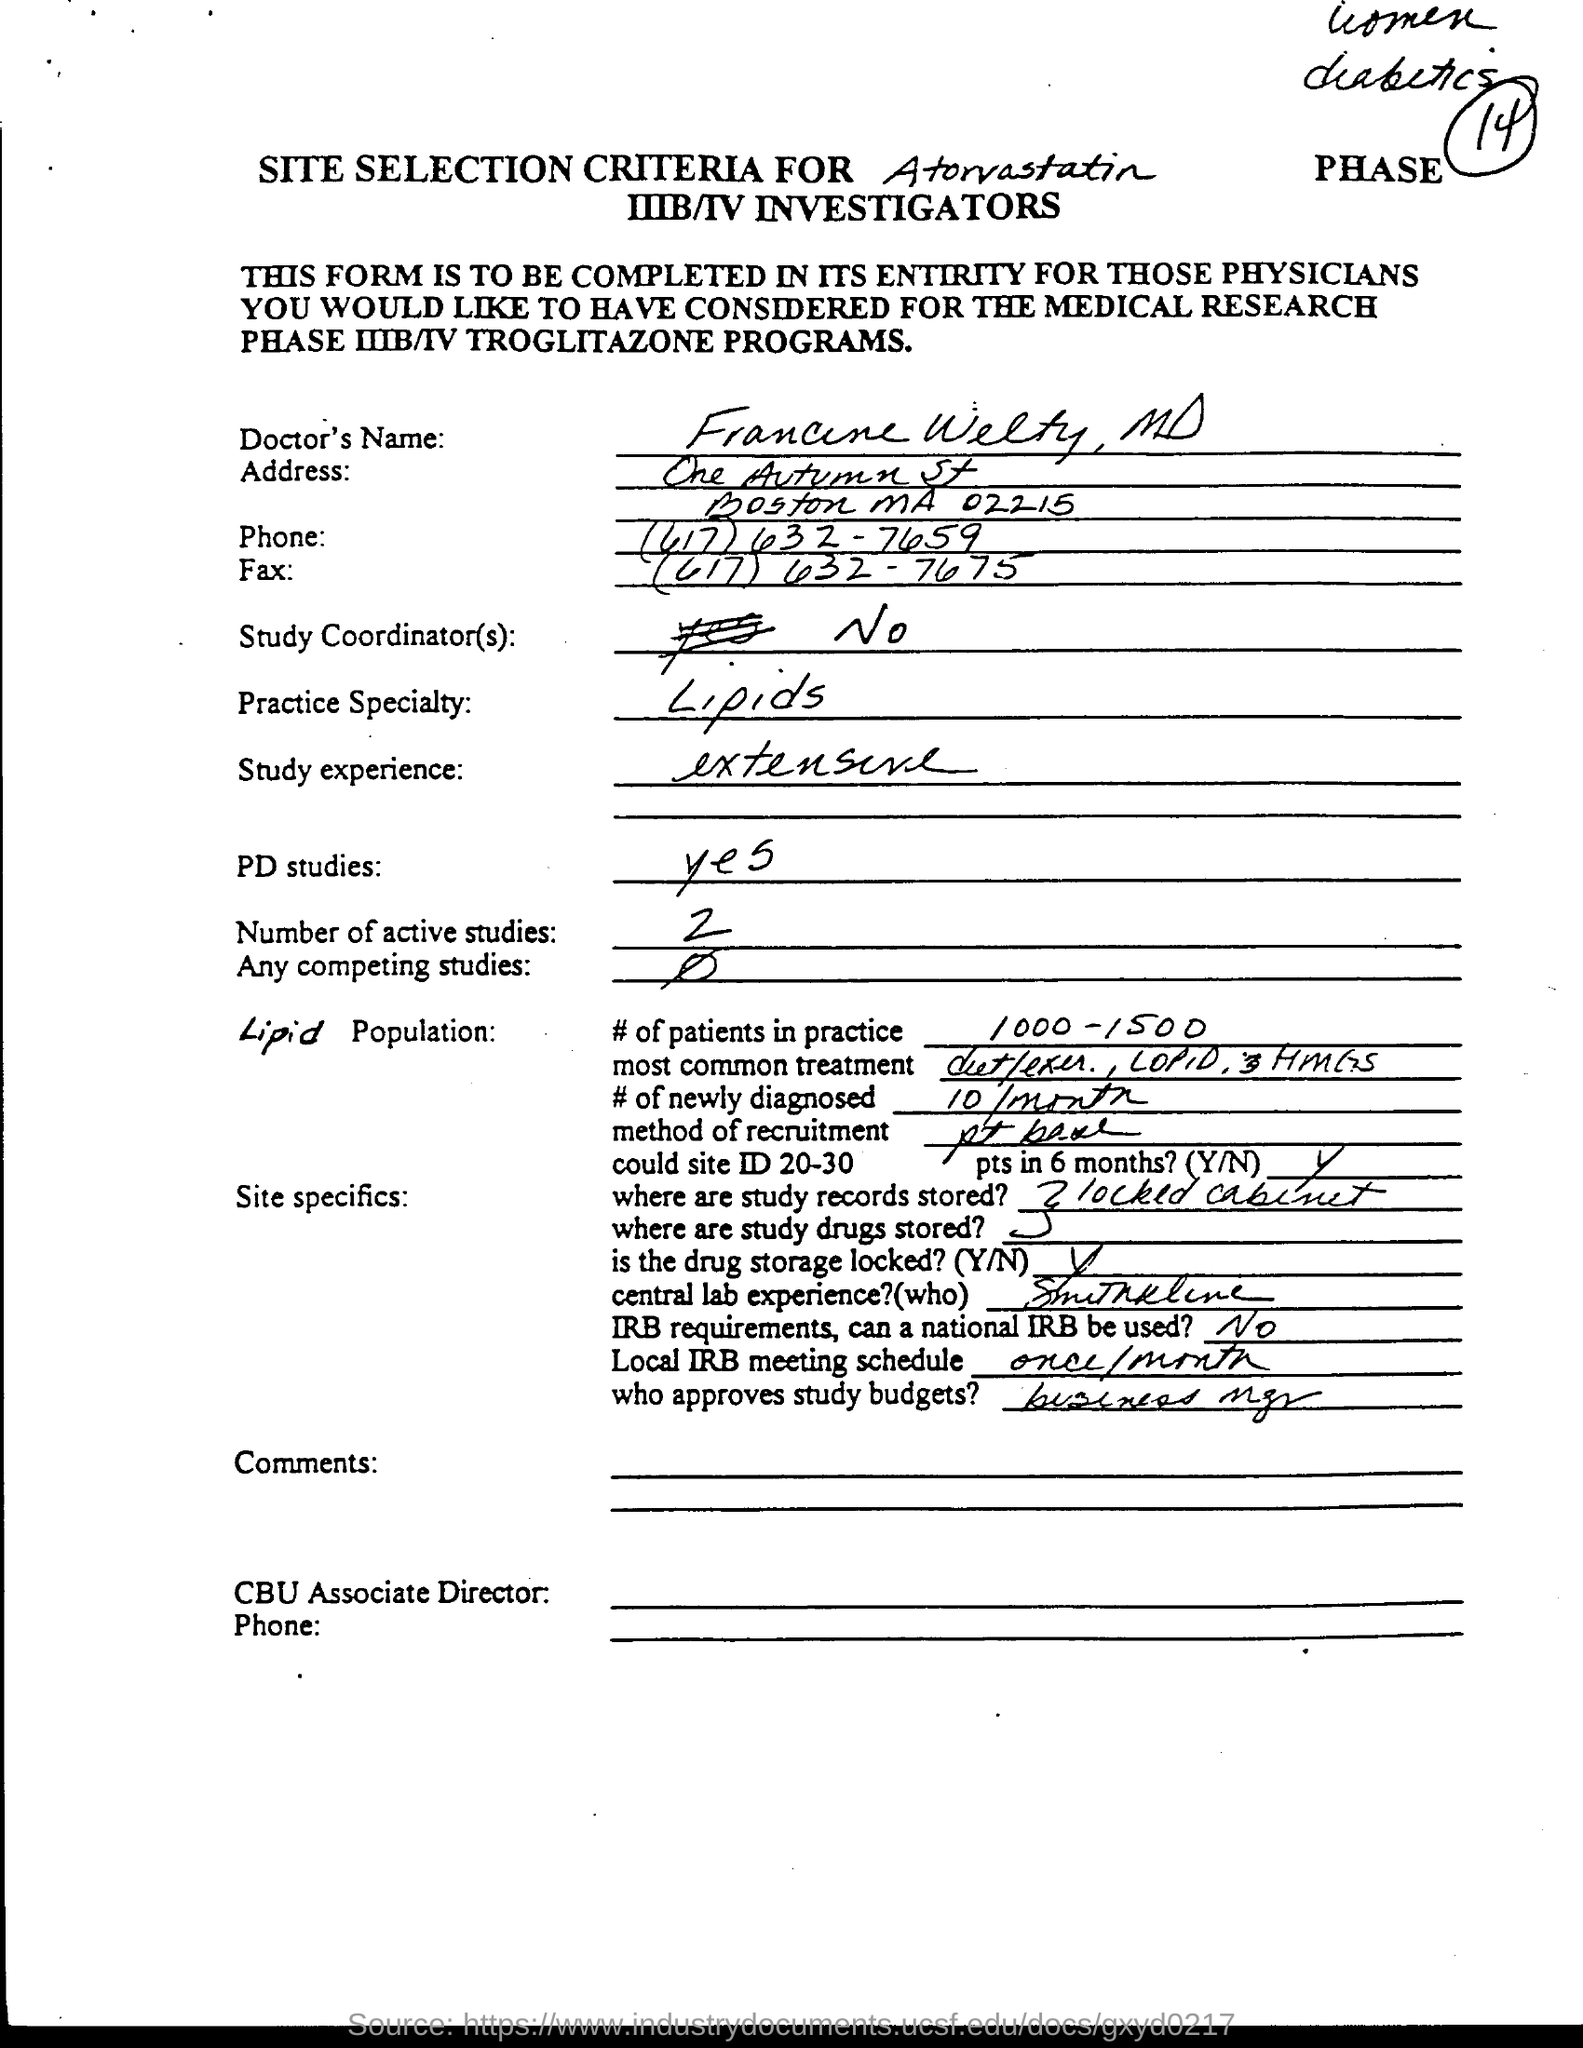Specify some key components in this picture. The number of patients in the practice ranges from 1000 to 1500. The local IRB meeting schedule takes place once a month. What is the study experience? Extensive research and analysis has shown that it is extensive. Lipids are the primary specialty of our practice. There are currently two active studies. 